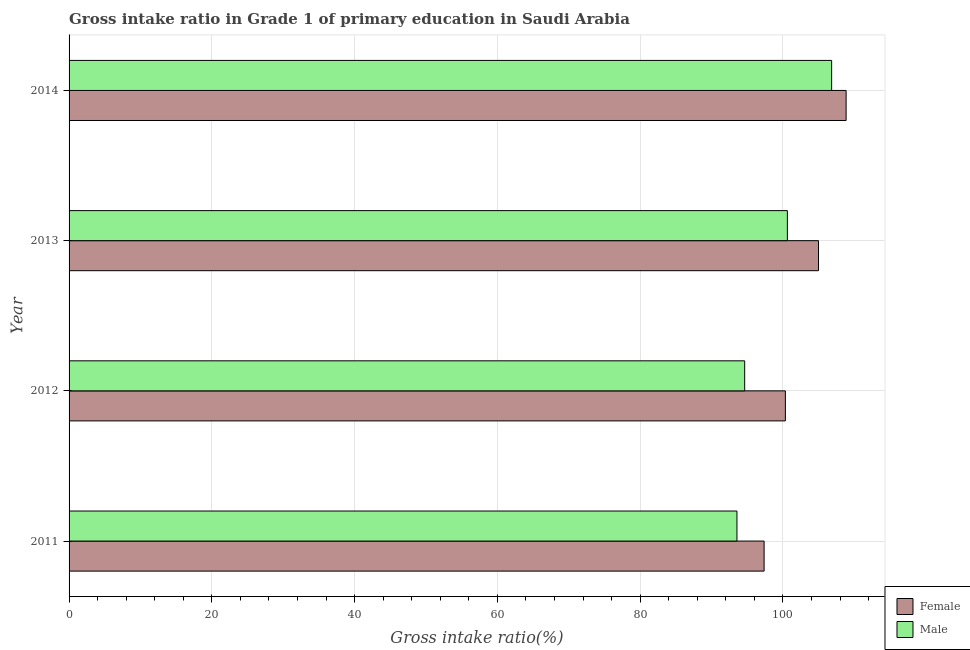How many bars are there on the 2nd tick from the top?
Provide a succinct answer. 2. What is the label of the 4th group of bars from the top?
Offer a terse response. 2011. What is the gross intake ratio(female) in 2014?
Your answer should be very brief. 108.86. Across all years, what is the maximum gross intake ratio(female)?
Provide a short and direct response. 108.86. Across all years, what is the minimum gross intake ratio(male)?
Ensure brevity in your answer.  93.56. What is the total gross intake ratio(male) in the graph?
Provide a short and direct response. 395.66. What is the difference between the gross intake ratio(female) in 2011 and that in 2013?
Give a very brief answer. -7.62. What is the difference between the gross intake ratio(male) in 2014 and the gross intake ratio(female) in 2013?
Ensure brevity in your answer.  1.84. What is the average gross intake ratio(male) per year?
Your response must be concise. 98.92. In the year 2013, what is the difference between the gross intake ratio(female) and gross intake ratio(male)?
Make the answer very short. 4.36. In how many years, is the gross intake ratio(male) greater than 104 %?
Ensure brevity in your answer.  1. What is the ratio of the gross intake ratio(male) in 2011 to that in 2014?
Provide a short and direct response. 0.88. Is the gross intake ratio(female) in 2011 less than that in 2013?
Offer a very short reply. Yes. What is the difference between the highest and the second highest gross intake ratio(male)?
Your response must be concise. 6.2. What is the difference between the highest and the lowest gross intake ratio(female)?
Your answer should be compact. 11.49. In how many years, is the gross intake ratio(female) greater than the average gross intake ratio(female) taken over all years?
Provide a short and direct response. 2. Is the sum of the gross intake ratio(male) in 2011 and 2014 greater than the maximum gross intake ratio(female) across all years?
Your answer should be compact. Yes. What does the 2nd bar from the bottom in 2011 represents?
Ensure brevity in your answer.  Male. How many bars are there?
Your answer should be compact. 8. Are all the bars in the graph horizontal?
Ensure brevity in your answer.  Yes. How many years are there in the graph?
Your response must be concise. 4. What is the difference between two consecutive major ticks on the X-axis?
Provide a short and direct response. 20. Are the values on the major ticks of X-axis written in scientific E-notation?
Ensure brevity in your answer.  No. Does the graph contain any zero values?
Offer a terse response. No. Does the graph contain grids?
Give a very brief answer. Yes. How are the legend labels stacked?
Provide a short and direct response. Vertical. What is the title of the graph?
Make the answer very short. Gross intake ratio in Grade 1 of primary education in Saudi Arabia. What is the label or title of the X-axis?
Offer a very short reply. Gross intake ratio(%). What is the Gross intake ratio(%) of Female in 2011?
Your answer should be compact. 97.37. What is the Gross intake ratio(%) in Male in 2011?
Offer a terse response. 93.56. What is the Gross intake ratio(%) of Female in 2012?
Ensure brevity in your answer.  100.35. What is the Gross intake ratio(%) in Male in 2012?
Offer a terse response. 94.65. What is the Gross intake ratio(%) of Female in 2013?
Provide a succinct answer. 104.99. What is the Gross intake ratio(%) in Male in 2013?
Your answer should be compact. 100.63. What is the Gross intake ratio(%) in Female in 2014?
Your answer should be very brief. 108.86. What is the Gross intake ratio(%) of Male in 2014?
Your answer should be very brief. 106.83. Across all years, what is the maximum Gross intake ratio(%) of Female?
Offer a very short reply. 108.86. Across all years, what is the maximum Gross intake ratio(%) of Male?
Your response must be concise. 106.83. Across all years, what is the minimum Gross intake ratio(%) in Female?
Keep it short and to the point. 97.37. Across all years, what is the minimum Gross intake ratio(%) in Male?
Keep it short and to the point. 93.56. What is the total Gross intake ratio(%) of Female in the graph?
Offer a terse response. 411.56. What is the total Gross intake ratio(%) in Male in the graph?
Your response must be concise. 395.66. What is the difference between the Gross intake ratio(%) in Female in 2011 and that in 2012?
Offer a terse response. -2.98. What is the difference between the Gross intake ratio(%) in Male in 2011 and that in 2012?
Your answer should be very brief. -1.08. What is the difference between the Gross intake ratio(%) of Female in 2011 and that in 2013?
Ensure brevity in your answer.  -7.62. What is the difference between the Gross intake ratio(%) of Male in 2011 and that in 2013?
Provide a succinct answer. -7.06. What is the difference between the Gross intake ratio(%) in Female in 2011 and that in 2014?
Provide a short and direct response. -11.49. What is the difference between the Gross intake ratio(%) of Male in 2011 and that in 2014?
Offer a very short reply. -13.26. What is the difference between the Gross intake ratio(%) of Female in 2012 and that in 2013?
Your answer should be very brief. -4.64. What is the difference between the Gross intake ratio(%) in Male in 2012 and that in 2013?
Your answer should be compact. -5.98. What is the difference between the Gross intake ratio(%) in Female in 2012 and that in 2014?
Your answer should be compact. -8.51. What is the difference between the Gross intake ratio(%) in Male in 2012 and that in 2014?
Keep it short and to the point. -12.18. What is the difference between the Gross intake ratio(%) of Female in 2013 and that in 2014?
Make the answer very short. -3.87. What is the difference between the Gross intake ratio(%) of Male in 2013 and that in 2014?
Offer a terse response. -6.2. What is the difference between the Gross intake ratio(%) of Female in 2011 and the Gross intake ratio(%) of Male in 2012?
Your answer should be compact. 2.72. What is the difference between the Gross intake ratio(%) in Female in 2011 and the Gross intake ratio(%) in Male in 2013?
Provide a succinct answer. -3.26. What is the difference between the Gross intake ratio(%) in Female in 2011 and the Gross intake ratio(%) in Male in 2014?
Make the answer very short. -9.46. What is the difference between the Gross intake ratio(%) of Female in 2012 and the Gross intake ratio(%) of Male in 2013?
Your response must be concise. -0.28. What is the difference between the Gross intake ratio(%) in Female in 2012 and the Gross intake ratio(%) in Male in 2014?
Your answer should be compact. -6.48. What is the difference between the Gross intake ratio(%) of Female in 2013 and the Gross intake ratio(%) of Male in 2014?
Offer a very short reply. -1.84. What is the average Gross intake ratio(%) of Female per year?
Your response must be concise. 102.89. What is the average Gross intake ratio(%) of Male per year?
Ensure brevity in your answer.  98.92. In the year 2011, what is the difference between the Gross intake ratio(%) in Female and Gross intake ratio(%) in Male?
Your answer should be very brief. 3.8. In the year 2012, what is the difference between the Gross intake ratio(%) of Female and Gross intake ratio(%) of Male?
Give a very brief answer. 5.7. In the year 2013, what is the difference between the Gross intake ratio(%) in Female and Gross intake ratio(%) in Male?
Make the answer very short. 4.36. In the year 2014, what is the difference between the Gross intake ratio(%) of Female and Gross intake ratio(%) of Male?
Keep it short and to the point. 2.03. What is the ratio of the Gross intake ratio(%) in Female in 2011 to that in 2012?
Your answer should be compact. 0.97. What is the ratio of the Gross intake ratio(%) of Female in 2011 to that in 2013?
Give a very brief answer. 0.93. What is the ratio of the Gross intake ratio(%) of Male in 2011 to that in 2013?
Keep it short and to the point. 0.93. What is the ratio of the Gross intake ratio(%) of Female in 2011 to that in 2014?
Make the answer very short. 0.89. What is the ratio of the Gross intake ratio(%) of Male in 2011 to that in 2014?
Provide a succinct answer. 0.88. What is the ratio of the Gross intake ratio(%) of Female in 2012 to that in 2013?
Offer a terse response. 0.96. What is the ratio of the Gross intake ratio(%) of Male in 2012 to that in 2013?
Make the answer very short. 0.94. What is the ratio of the Gross intake ratio(%) of Female in 2012 to that in 2014?
Give a very brief answer. 0.92. What is the ratio of the Gross intake ratio(%) in Male in 2012 to that in 2014?
Your response must be concise. 0.89. What is the ratio of the Gross intake ratio(%) of Female in 2013 to that in 2014?
Provide a short and direct response. 0.96. What is the ratio of the Gross intake ratio(%) of Male in 2013 to that in 2014?
Keep it short and to the point. 0.94. What is the difference between the highest and the second highest Gross intake ratio(%) of Female?
Keep it short and to the point. 3.87. What is the difference between the highest and the second highest Gross intake ratio(%) of Male?
Provide a succinct answer. 6.2. What is the difference between the highest and the lowest Gross intake ratio(%) of Female?
Provide a short and direct response. 11.49. What is the difference between the highest and the lowest Gross intake ratio(%) of Male?
Your answer should be compact. 13.26. 